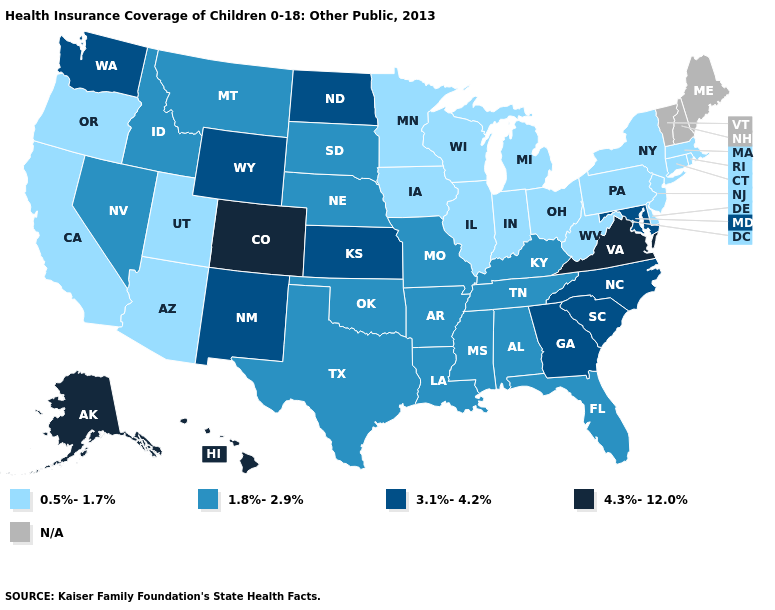Name the states that have a value in the range N/A?
Keep it brief. Maine, New Hampshire, Vermont. What is the value of West Virginia?
Keep it brief. 0.5%-1.7%. What is the value of Arkansas?
Write a very short answer. 1.8%-2.9%. What is the lowest value in the USA?
Write a very short answer. 0.5%-1.7%. What is the value of Indiana?
Keep it brief. 0.5%-1.7%. What is the value of Ohio?
Short answer required. 0.5%-1.7%. Name the states that have a value in the range 1.8%-2.9%?
Give a very brief answer. Alabama, Arkansas, Florida, Idaho, Kentucky, Louisiana, Mississippi, Missouri, Montana, Nebraska, Nevada, Oklahoma, South Dakota, Tennessee, Texas. Is the legend a continuous bar?
Be succinct. No. Name the states that have a value in the range N/A?
Write a very short answer. Maine, New Hampshire, Vermont. Name the states that have a value in the range 3.1%-4.2%?
Keep it brief. Georgia, Kansas, Maryland, New Mexico, North Carolina, North Dakota, South Carolina, Washington, Wyoming. Name the states that have a value in the range N/A?
Write a very short answer. Maine, New Hampshire, Vermont. What is the value of Montana?
Concise answer only. 1.8%-2.9%. 